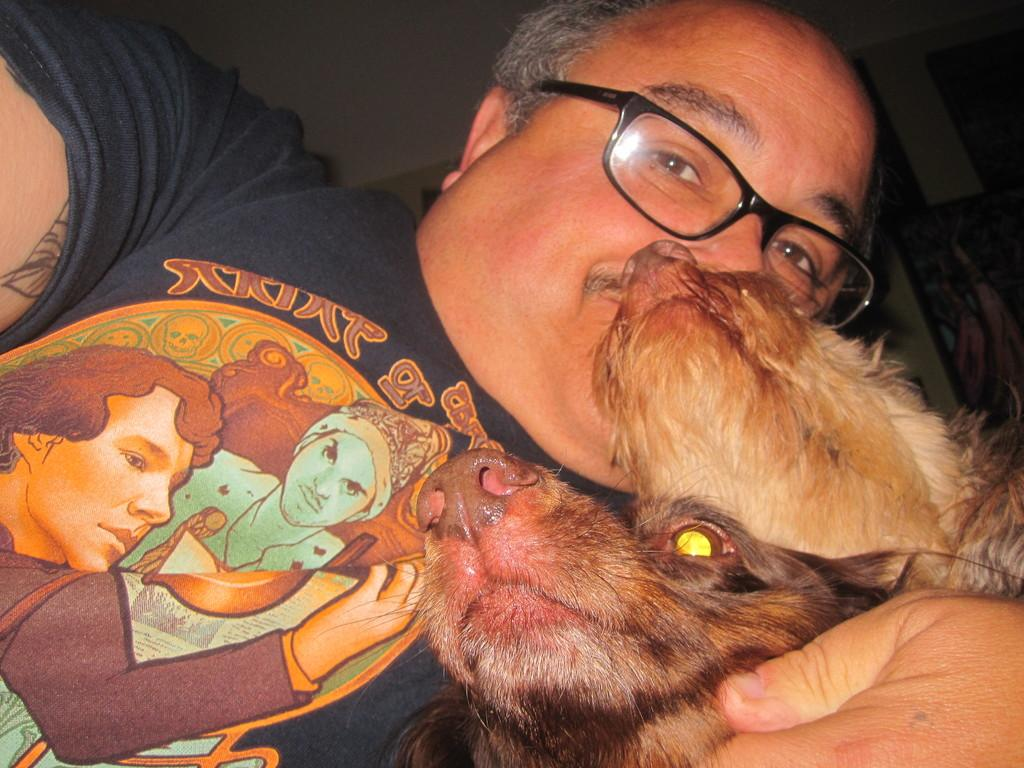What is present in the image? There is a man in the image. What is the man doing in the image? The man is holding a pet. What type of jeans is the man wearing in the image? There is no information about the man's clothing in the provided facts, so we cannot determine if he is wearing jeans or any other type of clothing. 